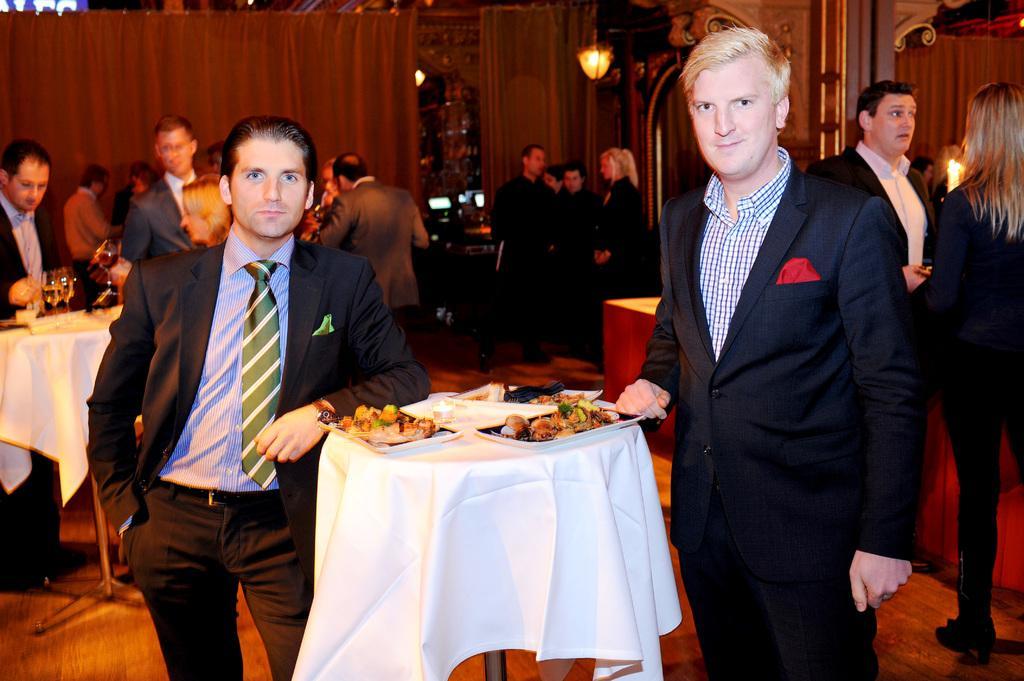Could you give a brief overview of what you see in this image? In the foreground of this image, there is a table on which there are platters with food. On either side to the table, there are men standing wearing suits. In the background, there are few people standing, and few are standing at the table on which there are glasses. At the top, there is a curtain, few lights and the wall. 